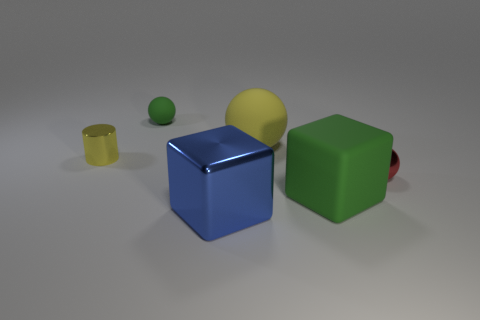Subtract all small green rubber balls. How many balls are left? 2 Add 1 big brown shiny spheres. How many objects exist? 7 Subtract all yellow balls. How many balls are left? 2 Subtract all cubes. How many objects are left? 4 Subtract all large rubber objects. Subtract all green things. How many objects are left? 2 Add 2 shiny balls. How many shiny balls are left? 3 Add 3 large blue cubes. How many large blue cubes exist? 4 Subtract 0 gray cubes. How many objects are left? 6 Subtract 1 cylinders. How many cylinders are left? 0 Subtract all blue blocks. Subtract all yellow balls. How many blocks are left? 1 